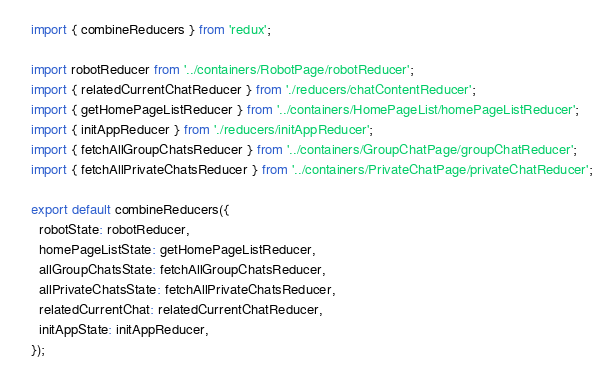Convert code to text. <code><loc_0><loc_0><loc_500><loc_500><_JavaScript_>import { combineReducers } from 'redux';

import robotReducer from '../containers/RobotPage/robotReducer';
import { relatedCurrentChatReducer } from './reducers/chatContentReducer';
import { getHomePageListReducer } from '../containers/HomePageList/homePageListReducer';
import { initAppReducer } from './reducers/initAppReducer';
import { fetchAllGroupChatsReducer } from '../containers/GroupChatPage/groupChatReducer';
import { fetchAllPrivateChatsReducer } from '../containers/PrivateChatPage/privateChatReducer';

export default combineReducers({
  robotState: robotReducer,
  homePageListState: getHomePageListReducer,
  allGroupChatsState: fetchAllGroupChatsReducer,
  allPrivateChatsState: fetchAllPrivateChatsReducer,
  relatedCurrentChat: relatedCurrentChatReducer,
  initAppState: initAppReducer,
});
</code> 